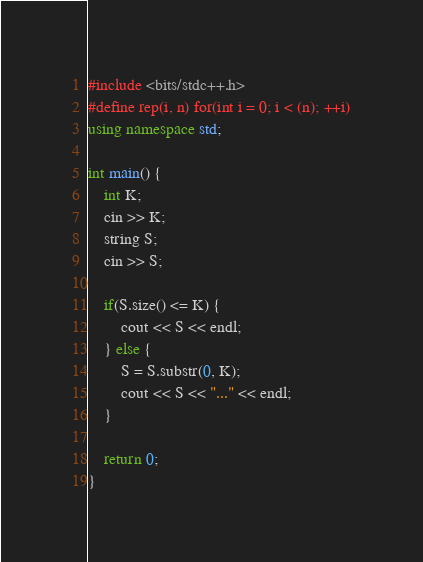<code> <loc_0><loc_0><loc_500><loc_500><_C++_>#include <bits/stdc++.h>
#define rep(i, n) for(int i = 0; i < (n); ++i)
using namespace std;

int main() {
	int K;
	cin >> K;
	string S;
	cin >> S;

	if(S.size() <= K) {
		cout << S << endl;
	} else {
		S = S.substr(0, K);
		cout << S << "..." << endl;
	}

	return 0;
}</code> 